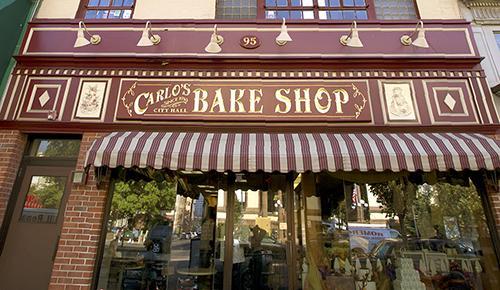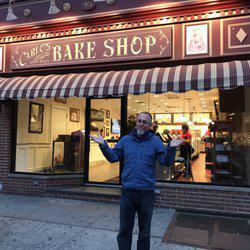The first image is the image on the left, the second image is the image on the right. Analyze the images presented: Is the assertion "There is a man with his  palms facing up." valid? Answer yes or no. Yes. 